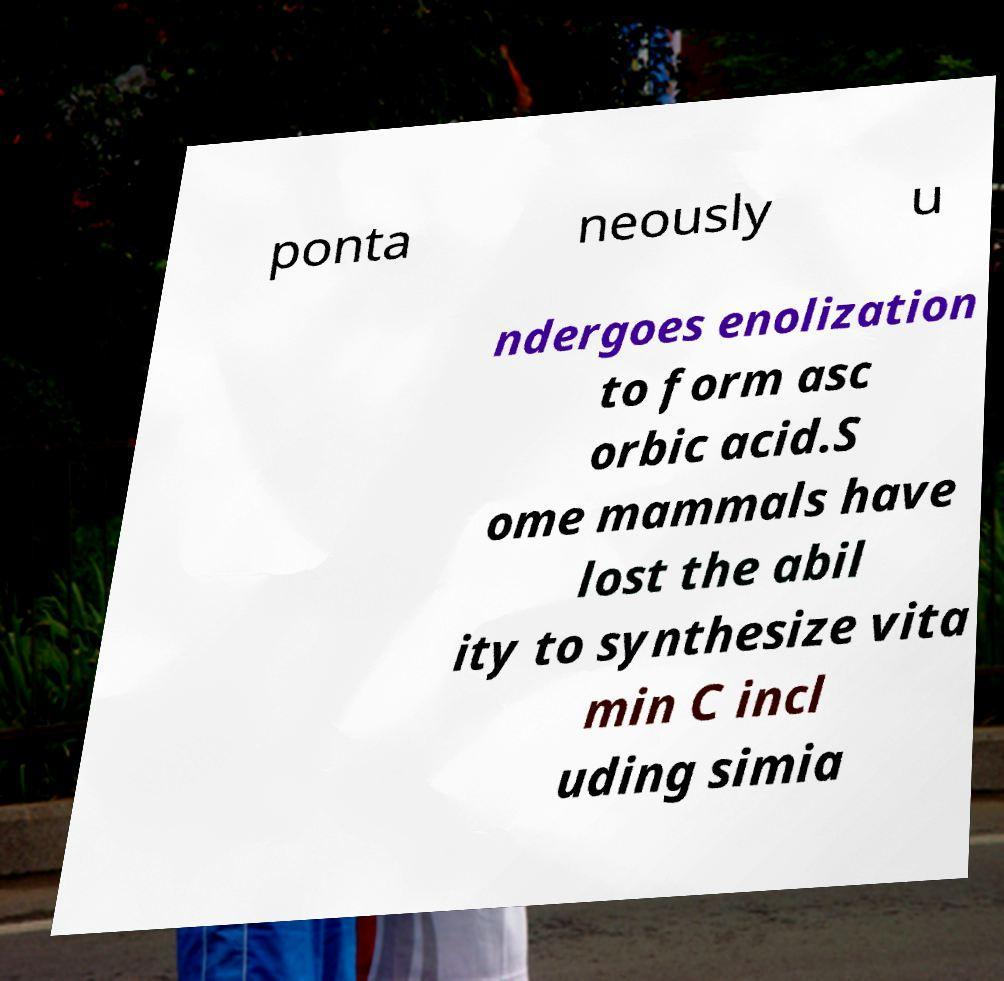I need the written content from this picture converted into text. Can you do that? ponta neously u ndergoes enolization to form asc orbic acid.S ome mammals have lost the abil ity to synthesize vita min C incl uding simia 